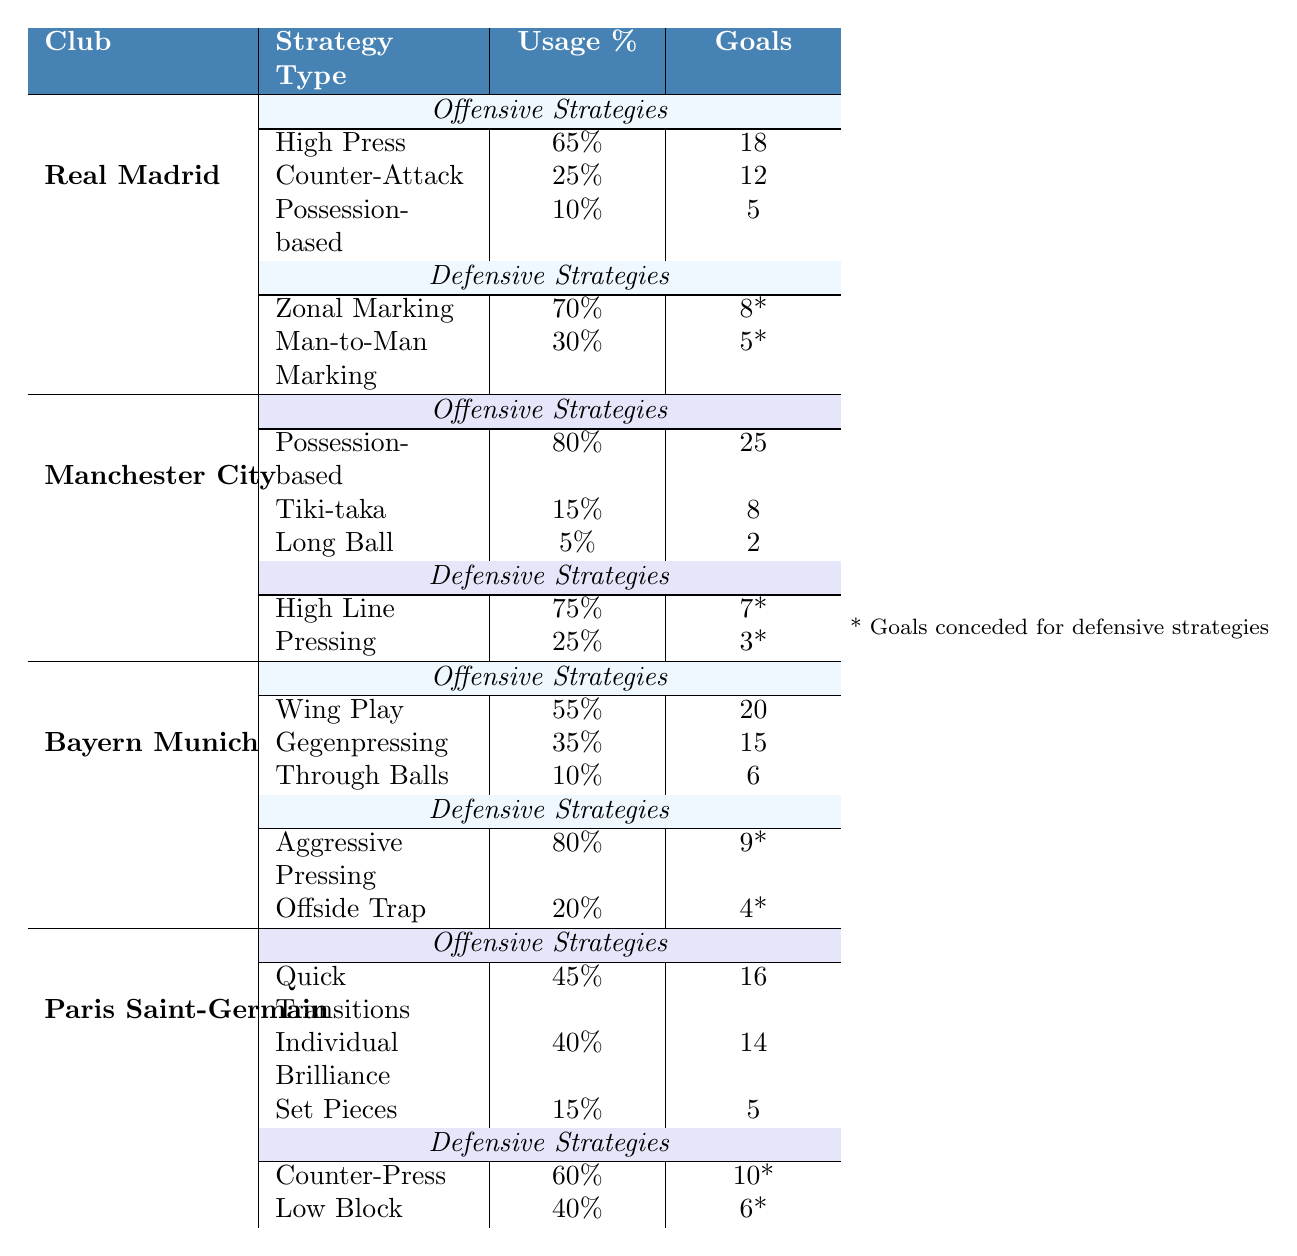What is the strategy with the highest usage percentage for Real Madrid's offensive play? According to the table, Real Madrid's offensive strategy with the highest usage percentage is "High Press," which is at 65%.
Answer: High Press Which club scored the most goals using possession-based offensive strategies? Looking at the data, Manchester City scored 25 goals using possession-based strategies, which is more than Real Madrid (5 goals) and Bayern Munich (6 goals).
Answer: Manchester City Did Bayern Munich use 'Offside Trap' more than 20% of the time? The table shows that Bayern Munich used the 'Offside Trap' strategy 20% of the time, which is not more than 20%.
Answer: No What is the total number of goals scored by Paris Saint-Germain using individual offensive strategies? Summing up the goals: Quick Transitions (16) + Individual Brilliance (14) + Set Pieces (5) = 35.
Answer: 35 Which club had the lowest number of goals conceded via 'Man-to-Man Marking'? The table indicates that Real Madrid had the lowest number of goals conceded (5) using 'Man-to-Man Marking' compared to the goals conceded for other clubs under their defensive strategies.
Answer: Real Madrid What are the combined goals scored by Bayern Munich through 'Gegenpressing' and 'Wing Play'? By examining the table, Bayern Munich scored 15 goals through 'Gegenpressing' and 20 through 'Wing Play'. Adding these gives us 15 + 20 = 35.
Answer: 35 Who implemented 'Counter-Press' in their defensive strategy and how many goals were conceded through it? The table lists Paris Saint-Germain as the club that used 'Counter-Press,' with 10 goals conceded through this strategy.
Answer: Paris Saint-Germain, 10 goals What's the average usage percentage of offensive strategies for Manchester City? The strategies are 80% for Possession-based, 15% for Tiki-taka, and 5% for Long Ball. The average is (80 + 15 + 5) / 3 = 33.33%.
Answer: 33.33% Which club used 'Aggressive Pressing' frequently and how does their goals conceded compare to the goals conceded by Manchester City under 'Pressing'? Bayern Munich used 'Aggressive Pressing' 80% of the time and conceded 9 goals, while Manchester City used 'Pressing' 25% of the time and conceded 3 goals. Bayern conceded more goals.
Answer: Bayern Munich, more goals Based on the data, can you say that the club with the most effective offensive strategy also has the least goals conceded? Real Madrid has the highest number of goals scored (18 with High Press) and conceded 8 goals with Zonal Marking, while it's not the least among all. Hence, this statement does not hold true.
Answer: No 